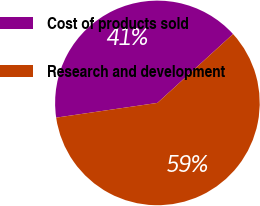<chart> <loc_0><loc_0><loc_500><loc_500><pie_chart><fcel>Cost of products sold<fcel>Research and development<nl><fcel>40.54%<fcel>59.46%<nl></chart> 